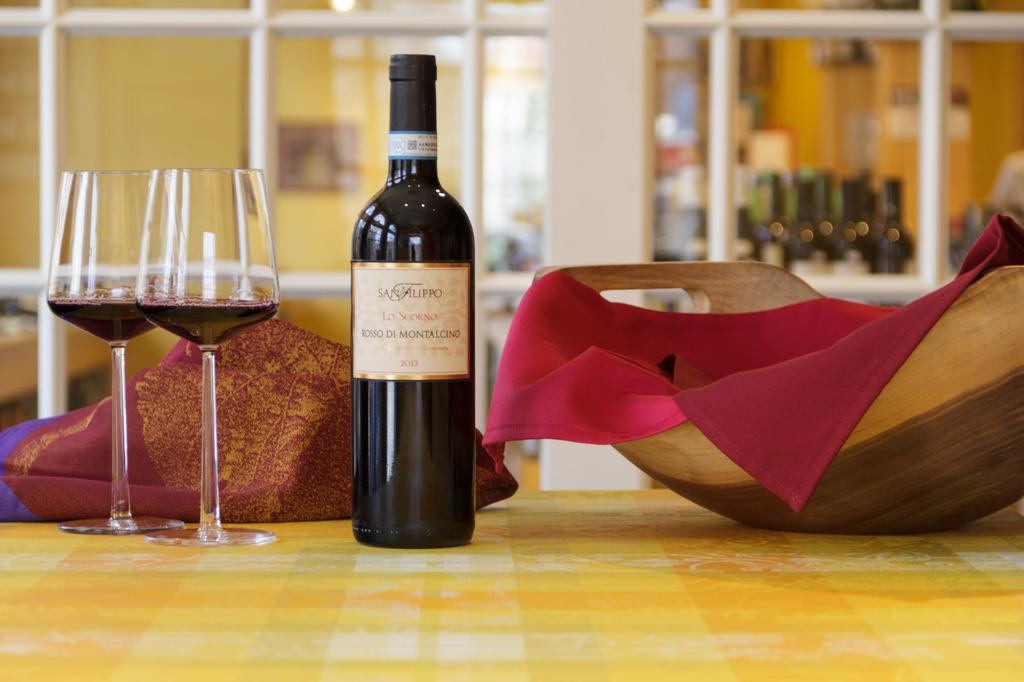<image>
Share a concise interpretation of the image provided. The type of wine shown here is Rosso Di Montalcino 